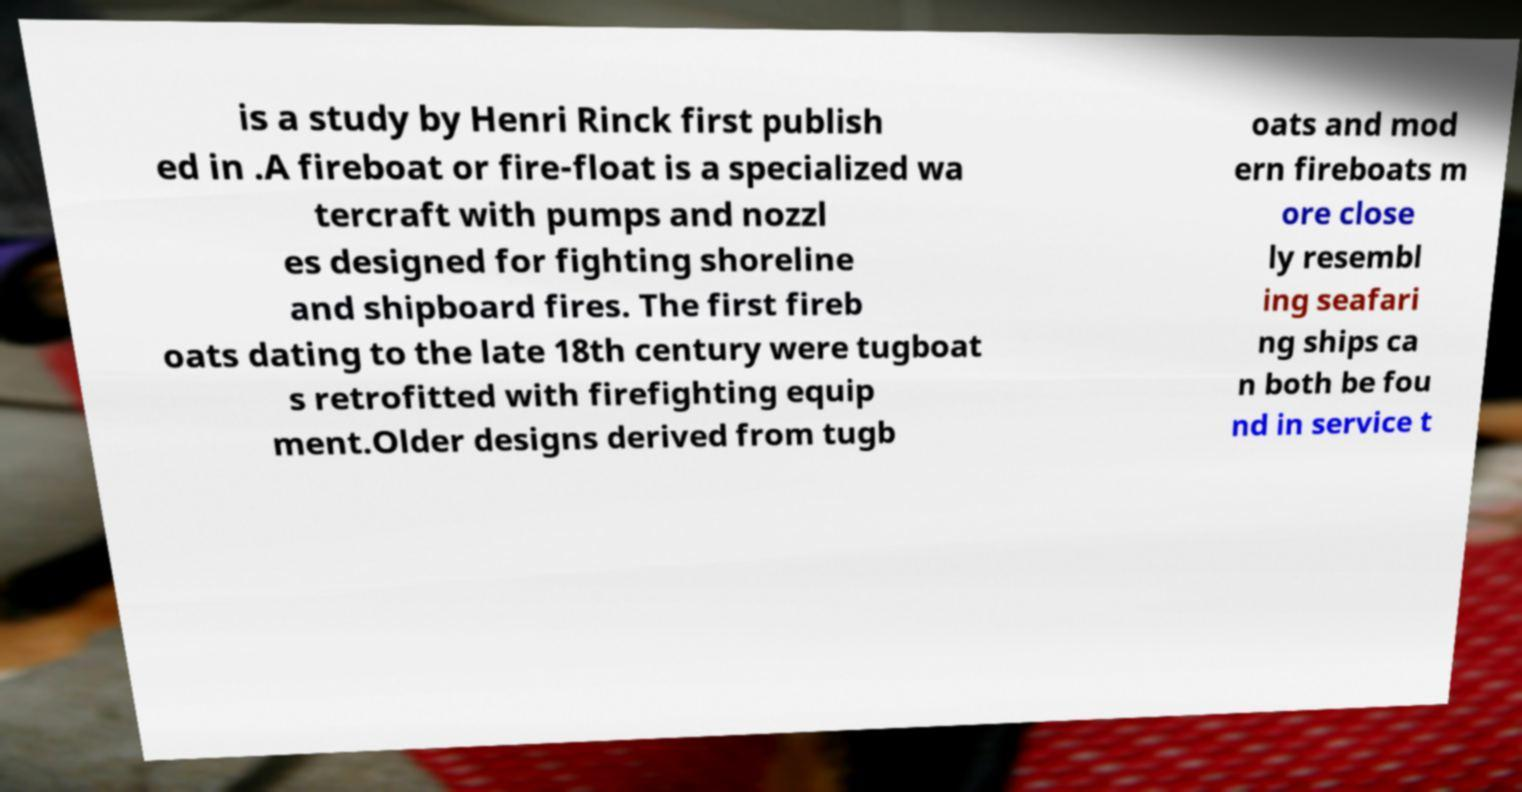Could you extract and type out the text from this image? is a study by Henri Rinck first publish ed in .A fireboat or fire-float is a specialized wa tercraft with pumps and nozzl es designed for fighting shoreline and shipboard fires. The first fireb oats dating to the late 18th century were tugboat s retrofitted with firefighting equip ment.Older designs derived from tugb oats and mod ern fireboats m ore close ly resembl ing seafari ng ships ca n both be fou nd in service t 